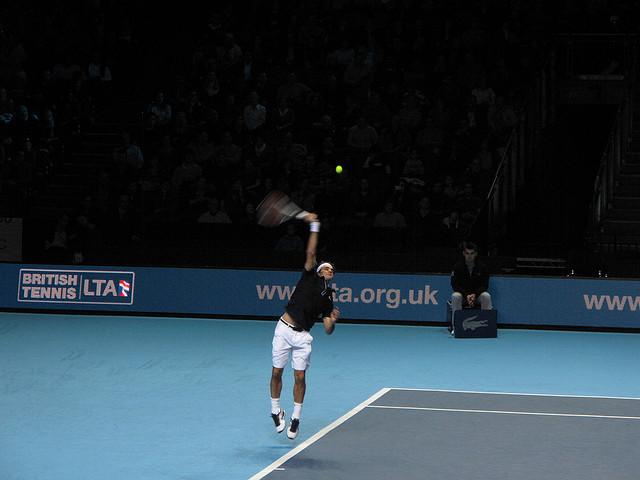Why is he wearing a wristband?
Write a very short answer. Sweat. Who is sponsoring the tennis match?
Give a very brief answer. Lta. What match is being played?
Concise answer only. Tennis. Are there people watching the tennis match?
Concise answer only. Yes. What is the man doing?
Be succinct. Playing tennis. What company is on the left side of the girl?
Keep it brief. British tennis lta. Who sponsor this game?
Be succinct. Lta. What tennis stroke is the man using?
Concise answer only. Forehand. What company's logo is partially shown?
Be succinct. Lta. What city is this taking place in?
Write a very short answer. London. What are the letters behind the tennis player?
Be succinct. Wwwtaorguk. How many balls are on the ground?
Keep it brief. 0. What URL is listed?
Answer briefly. Wwwltaorguk. What company's logo is shown?
Keep it brief. Lta. Is HyundaiCard one of the sponsors of this match?
Concise answer only. No. 